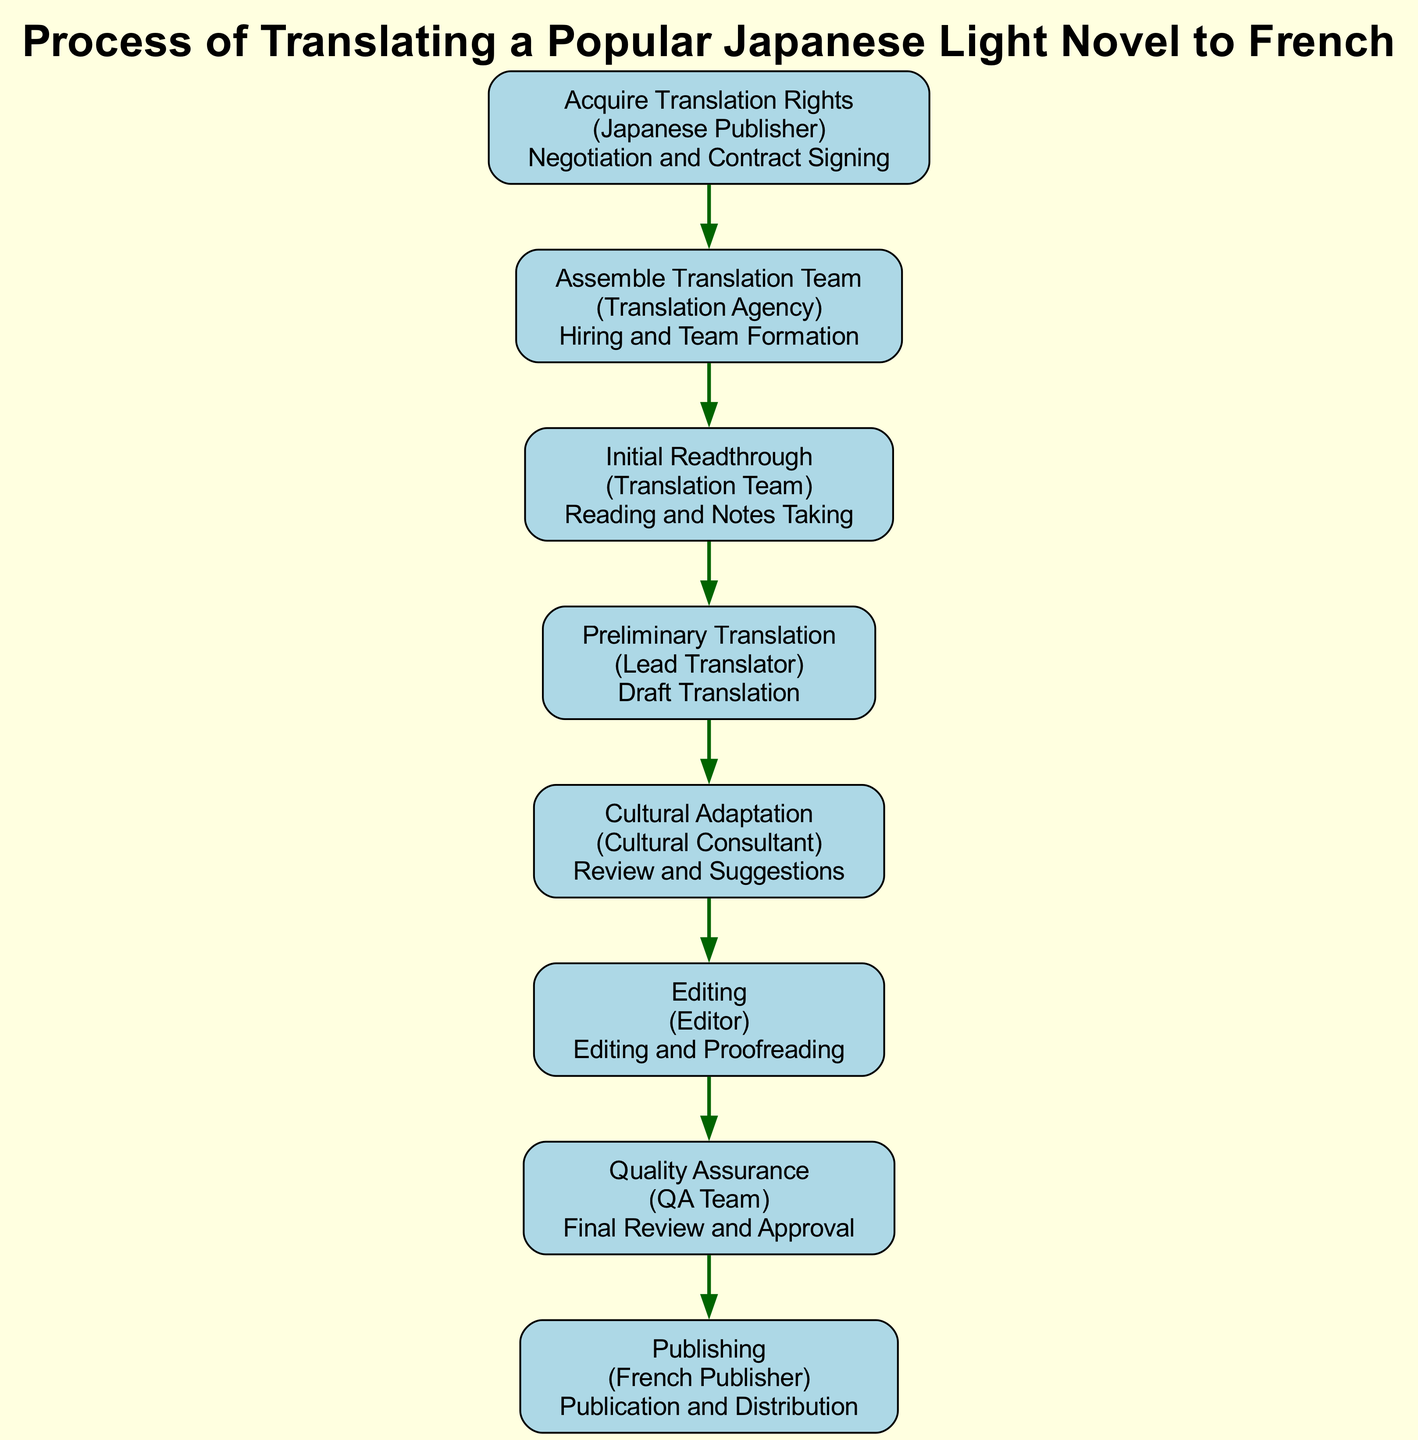What is the first step in the diagram? The first step in the diagram is labeled "Acquire Translation Rights," and it is the first node in the flow chart. This indicates it is the starting point of the process.
Answer: Acquire Translation Rights Which entity is involved in the "Editing" stage? The "Editing" stage specifies the entity as "Editor." This information is derived directly from the labeled node in the flow chart.
Answer: Editor How many steps are there in the process? To determine this, we count the total number of nodes in the flow chart. According to the provided data, there are eight distinct steps.
Answer: 8 What is the action associated with "Cultural Adaptation"? The action connected to "Cultural Adaptation" is "Review and Suggestions." This is mentioned explicitly in the respective node descriptor within the diagram.
Answer: Review and Suggestions What step comes after "Preliminary Translation"? The step that follows "Preliminary Translation" in the flow chart is "Cultural Adaptation." We observe the direct progression of nodes, illustrating the flow of the process.
Answer: Cultural Adaptation Which team conducts the "Quality Assurance"? The "Quality Assurance" step refers to the associated entity as "QA Team," highlighting who is responsible for this stage of the process.
Answer: QA Team What is the last step in the diagram? The last step shown in the flow chart is "Publishing." It appears as the final node in the sequence, indicating it is the concluding part of the entire process.
Answer: Publishing What action does a "Translation Agency" take during the process? The action indicated for the "Translation Agency" during the process is "Hiring and Team Formation," which is specifically stated in the respective node.
Answer: Hiring and Team Formation Which step is directly connected to the "Assemble Translation Team" step? The step that is directly connected to "Assemble Translation Team" is "Initial Readthrough," as inferred from the flow direction in the diagram.
Answer: Initial Readthrough 